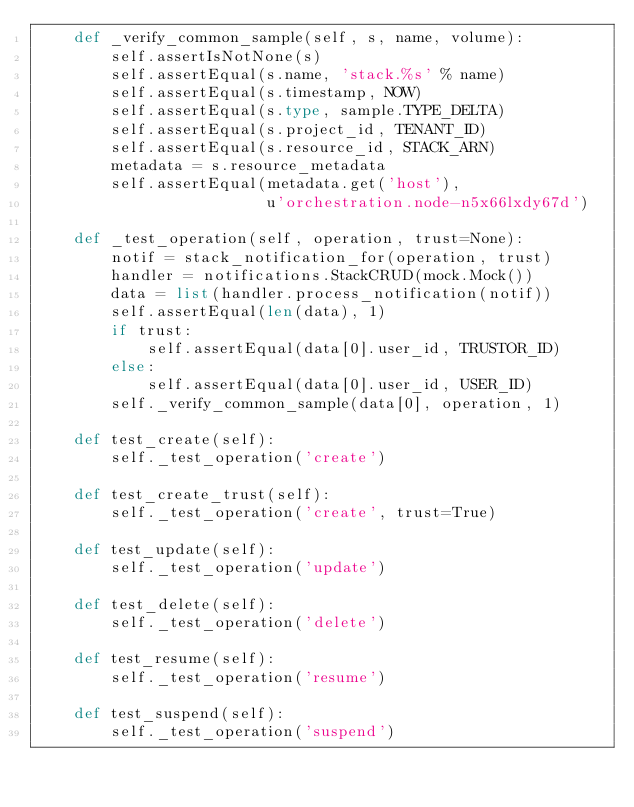<code> <loc_0><loc_0><loc_500><loc_500><_Python_>    def _verify_common_sample(self, s, name, volume):
        self.assertIsNotNone(s)
        self.assertEqual(s.name, 'stack.%s' % name)
        self.assertEqual(s.timestamp, NOW)
        self.assertEqual(s.type, sample.TYPE_DELTA)
        self.assertEqual(s.project_id, TENANT_ID)
        self.assertEqual(s.resource_id, STACK_ARN)
        metadata = s.resource_metadata
        self.assertEqual(metadata.get('host'),
                         u'orchestration.node-n5x66lxdy67d')

    def _test_operation(self, operation, trust=None):
        notif = stack_notification_for(operation, trust)
        handler = notifications.StackCRUD(mock.Mock())
        data = list(handler.process_notification(notif))
        self.assertEqual(len(data), 1)
        if trust:
            self.assertEqual(data[0].user_id, TRUSTOR_ID)
        else:
            self.assertEqual(data[0].user_id, USER_ID)
        self._verify_common_sample(data[0], operation, 1)

    def test_create(self):
        self._test_operation('create')

    def test_create_trust(self):
        self._test_operation('create', trust=True)

    def test_update(self):
        self._test_operation('update')

    def test_delete(self):
        self._test_operation('delete')

    def test_resume(self):
        self._test_operation('resume')

    def test_suspend(self):
        self._test_operation('suspend')
</code> 